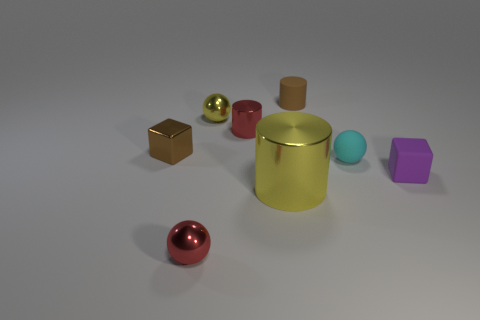Are there any brown objects of the same size as the purple thing?
Your answer should be very brief. Yes. Is the number of tiny rubber objects in front of the tiny purple rubber thing less than the number of green cylinders?
Provide a succinct answer. No. There is a tiny brown object behind the small metal ball that is behind the yellow metallic object in front of the tiny red shiny cylinder; what is its material?
Provide a short and direct response. Rubber. Is the number of red cylinders left of the small metallic cylinder greater than the number of purple rubber blocks on the right side of the small purple cube?
Offer a very short reply. No. How many metal things are either red balls or tiny balls?
Provide a succinct answer. 2. There is a thing that is the same color as the big metal cylinder; what shape is it?
Offer a terse response. Sphere. There is a large yellow cylinder left of the small rubber ball; what is its material?
Provide a succinct answer. Metal. How many objects are rubber balls or tiny brown objects on the left side of the red sphere?
Give a very brief answer. 2. What shape is the yellow metal object that is the same size as the rubber ball?
Your response must be concise. Sphere. How many other metallic blocks have the same color as the metal cube?
Your answer should be compact. 0. 